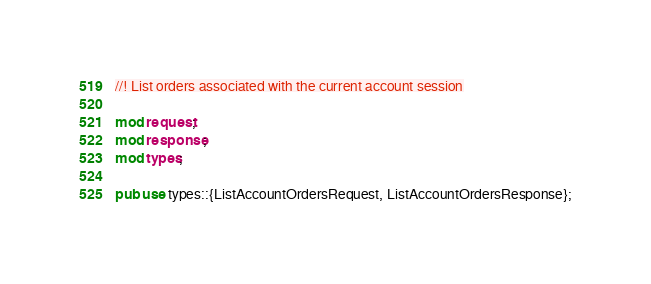<code> <loc_0><loc_0><loc_500><loc_500><_Rust_>//! List orders associated with the current account session

mod request;
mod response;
mod types;

pub use types::{ListAccountOrdersRequest, ListAccountOrdersResponse};
</code> 